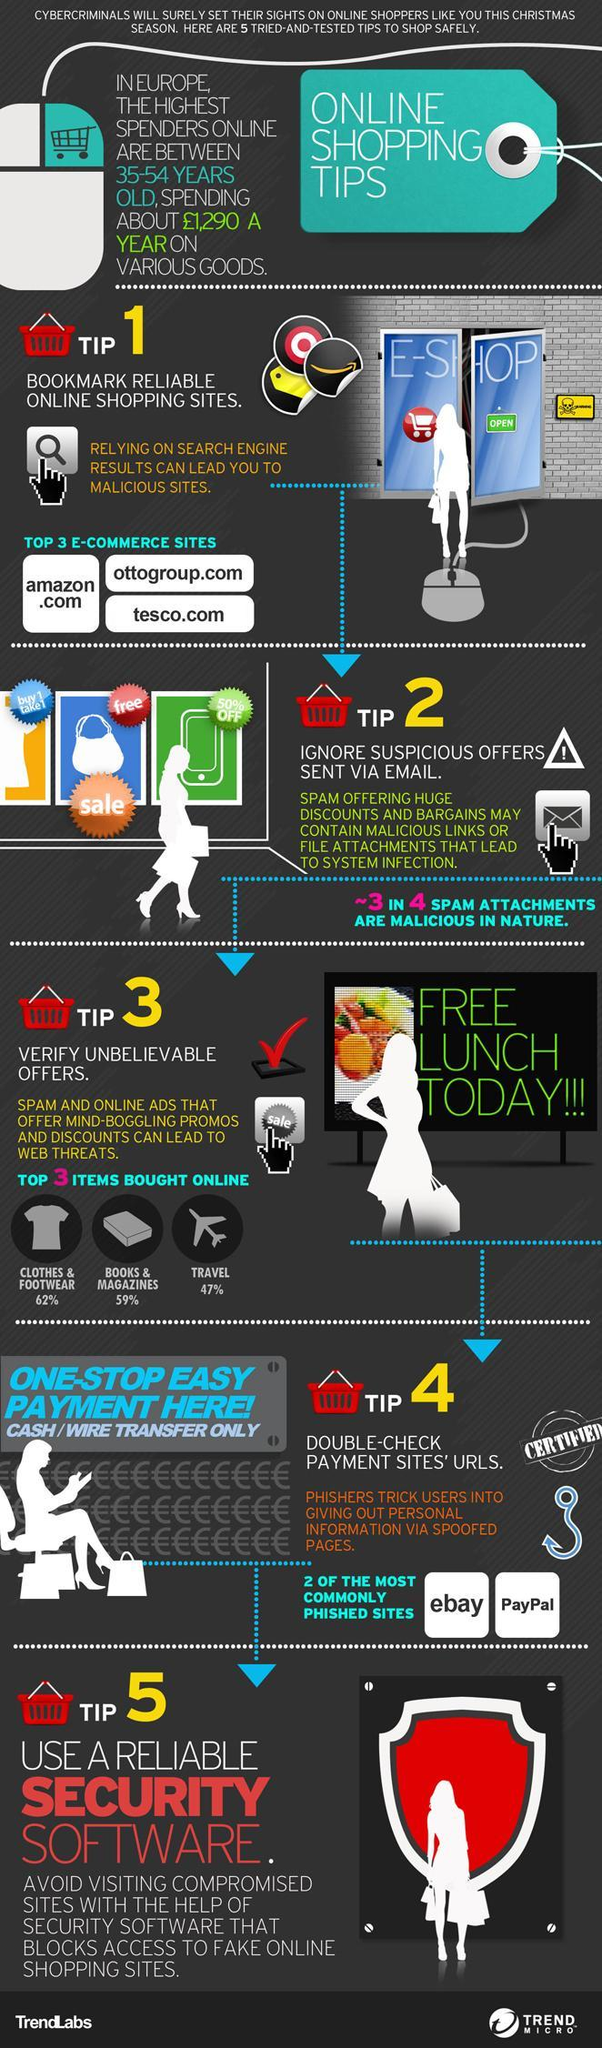What percentage of people buy books and magazines online?
Answer the question with a short phrase. 59% How many tips are mentioned here? 5 What 'percentage' of spam attachments are malicious? 75% What is the second last tip for safe online shopping? Double-check payment sites' URLS Which are the payment sites that are unsafe? eBay, PayPal Which are the top three items bought online? Clothes and footwear, books and magazines, travel What percentage of people buy clothes and footwear online? 62% Which are the top 3 eCommerce sites? Amazon.com, ottogroup.com, tesco.com 